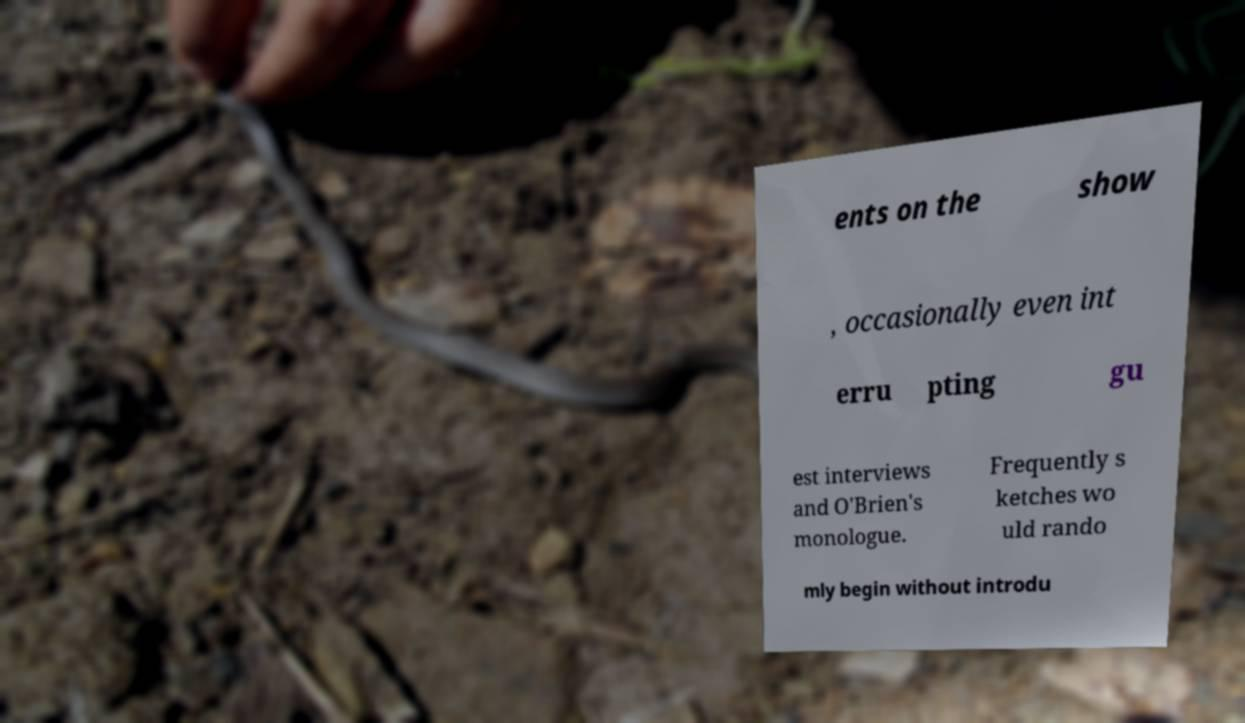Could you assist in decoding the text presented in this image and type it out clearly? ents on the show , occasionally even int erru pting gu est interviews and O'Brien's monologue. Frequently s ketches wo uld rando mly begin without introdu 